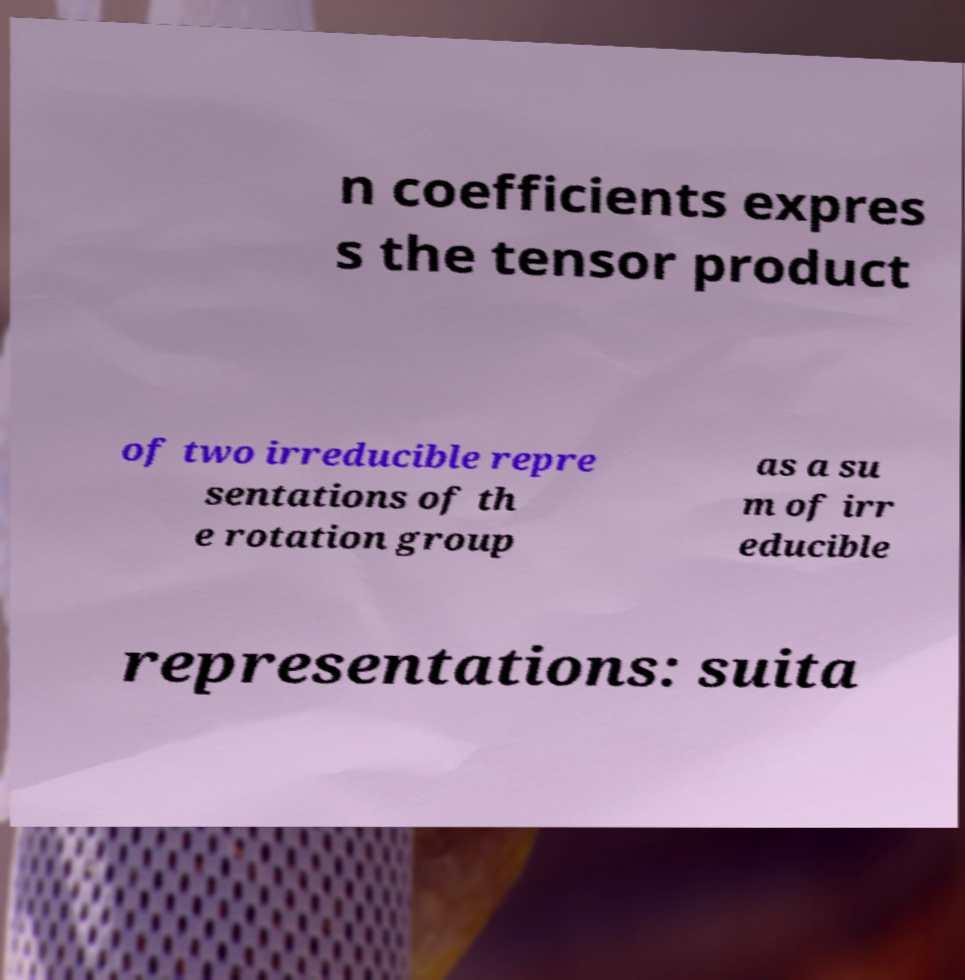There's text embedded in this image that I need extracted. Can you transcribe it verbatim? n coefficients expres s the tensor product of two irreducible repre sentations of th e rotation group as a su m of irr educible representations: suita 